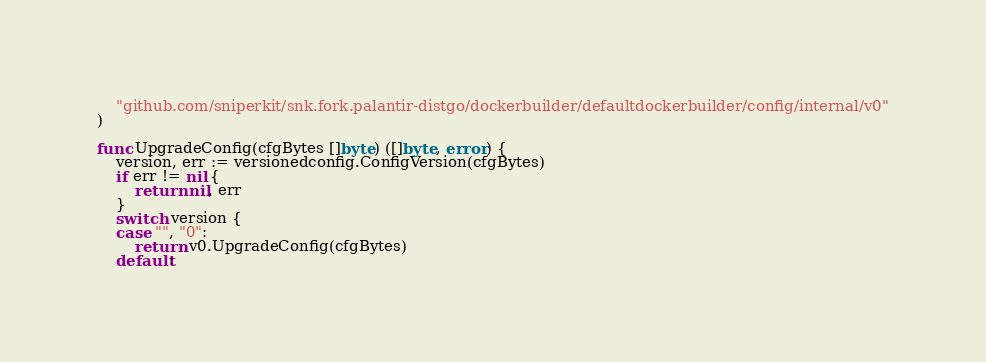<code> <loc_0><loc_0><loc_500><loc_500><_Go_>	"github.com/sniperkit/snk.fork.palantir-distgo/dockerbuilder/defaultdockerbuilder/config/internal/v0"
)

func UpgradeConfig(cfgBytes []byte) ([]byte, error) {
	version, err := versionedconfig.ConfigVersion(cfgBytes)
	if err != nil {
		return nil, err
	}
	switch version {
	case "", "0":
		return v0.UpgradeConfig(cfgBytes)
	default:</code> 